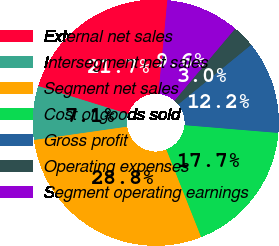Convert chart. <chart><loc_0><loc_0><loc_500><loc_500><pie_chart><fcel>External net sales<fcel>Intersegment net sales<fcel>Segment net sales<fcel>Cost of goods sold<fcel>Gross profit<fcel>Operating expenses<fcel>Segment operating earnings<nl><fcel>21.7%<fcel>7.06%<fcel>28.76%<fcel>17.66%<fcel>12.22%<fcel>2.95%<fcel>9.64%<nl></chart> 